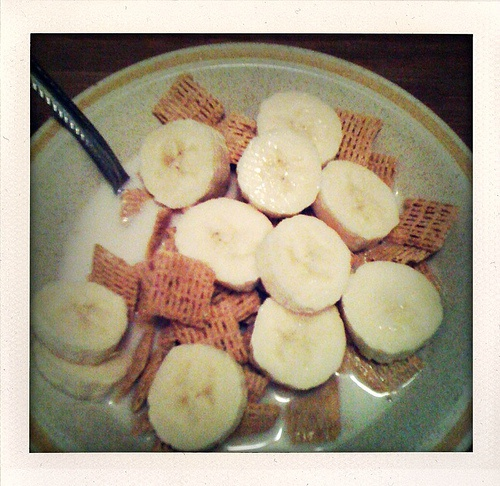Describe the objects in this image and their specific colors. I can see bowl in ivory, tan, gray, and brown tones, banana in ivory, tan, and gray tones, banana in ivory, beige, tan, and gray tones, banana in lightgray, beige, tan, and brown tones, and banana in beige and tan tones in this image. 